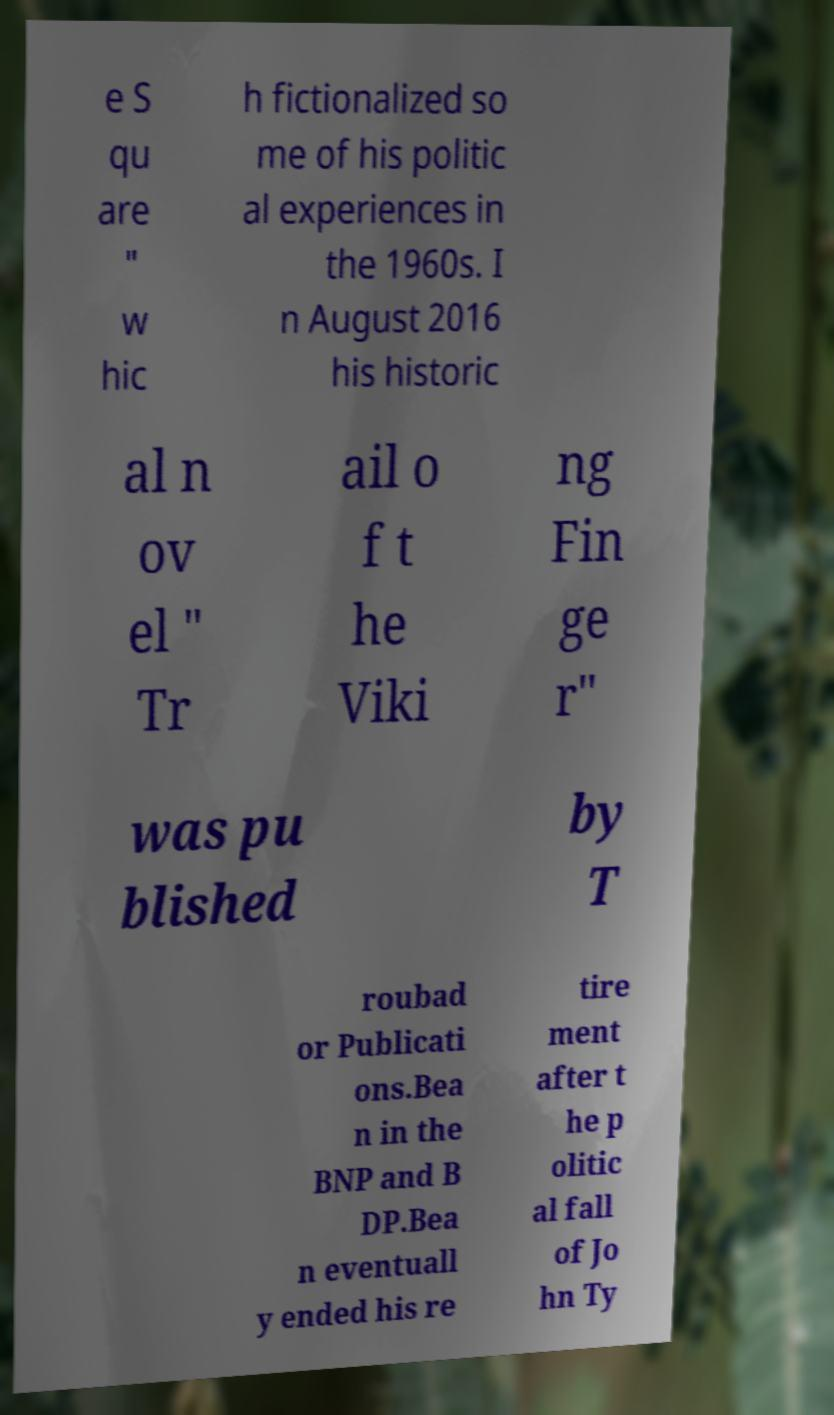Could you extract and type out the text from this image? e S qu are " w hic h fictionalized so me of his politic al experiences in the 1960s. I n August 2016 his historic al n ov el " Tr ail o f t he Viki ng Fin ge r" was pu blished by T roubad or Publicati ons.Bea n in the BNP and B DP.Bea n eventuall y ended his re tire ment after t he p olitic al fall of Jo hn Ty 